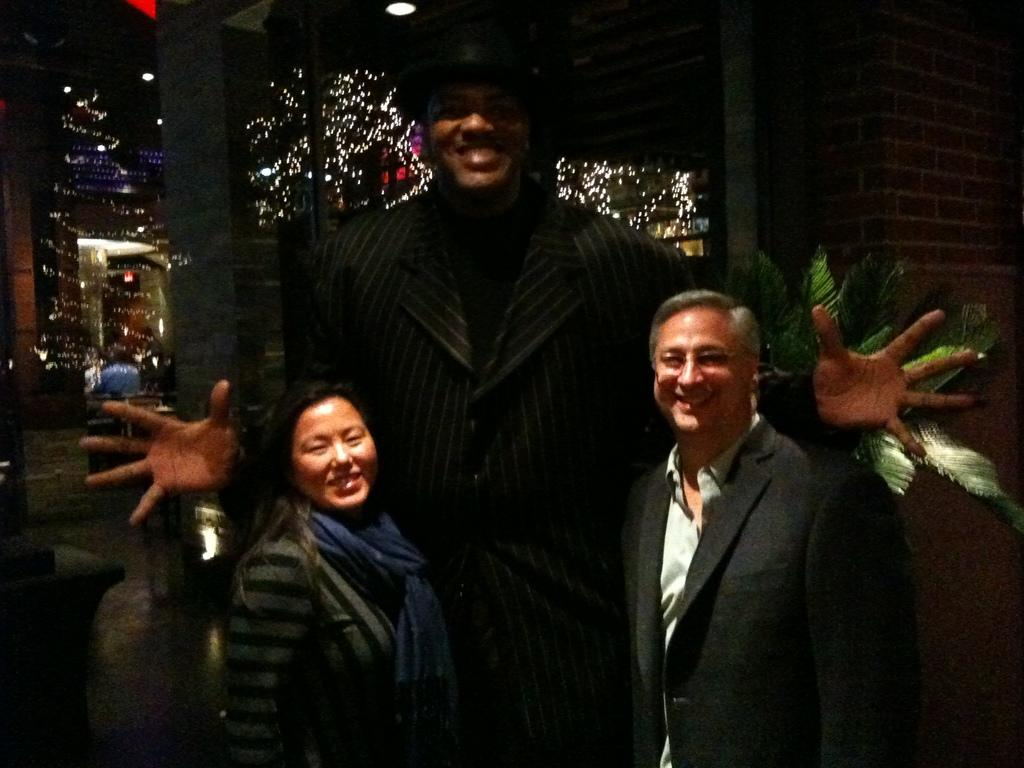How many people are in the image? There are three people standing in the image. What else can be seen in the image besides the people? House plants, a wall, decorative lights, and ceiling lights are visible in the image. What type of cup is being used to water the plants in the image? There is no cup visible in the image; the plants are not being watered. Are there any balloons present in the image? No, there are no balloons visible in the image. 